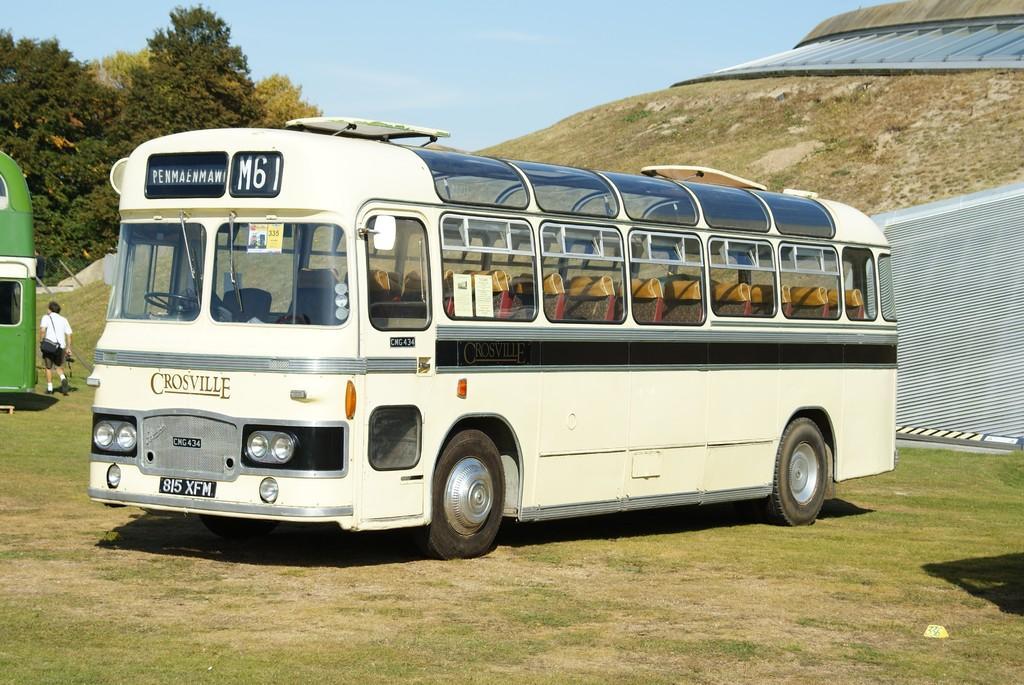Could you give a brief overview of what you see in this image? In this image I can see the vehicles on the ground. These vehicles are in cream and green color. To the left I can see one person wearing the white color dress and bag. In the background I can see mountain, trees and the blue sky. 